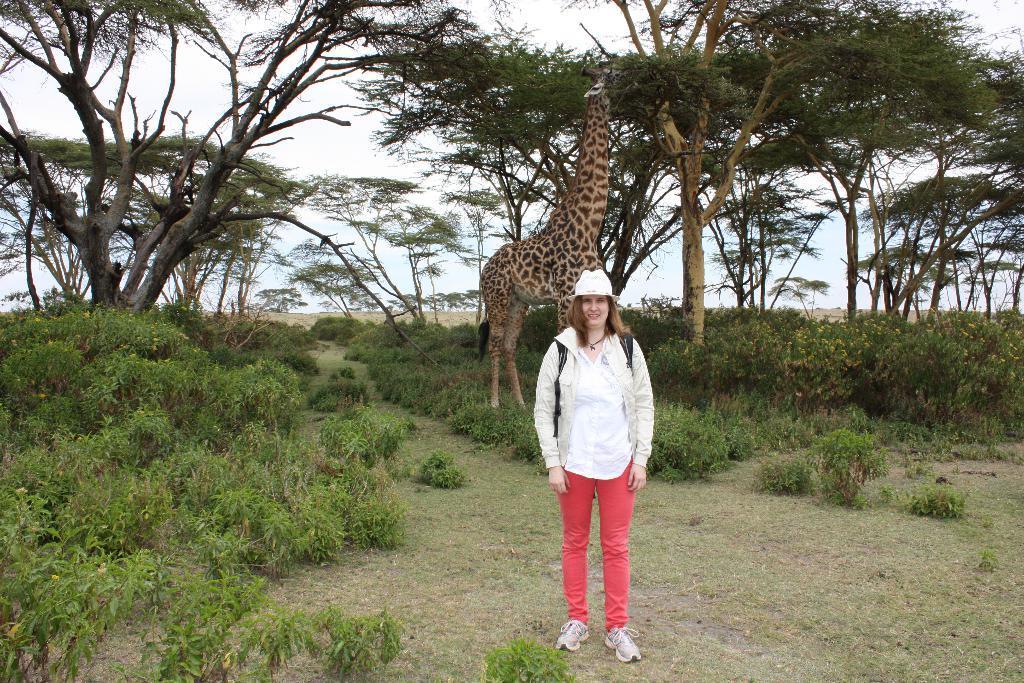Describe this image in one or two sentences. In this image we can see a woman standing and wearing a bag, behind her we can see a giraffe, there are some plants and trees, in the background we can see the sky. 